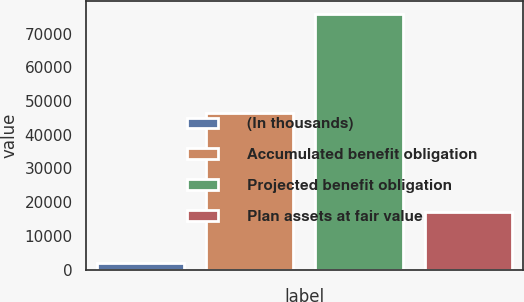Convert chart. <chart><loc_0><loc_0><loc_500><loc_500><bar_chart><fcel>(In thousands)<fcel>Accumulated benefit obligation<fcel>Projected benefit obligation<fcel>Plan assets at fair value<nl><fcel>2015<fcel>46419<fcel>75928<fcel>17038<nl></chart> 